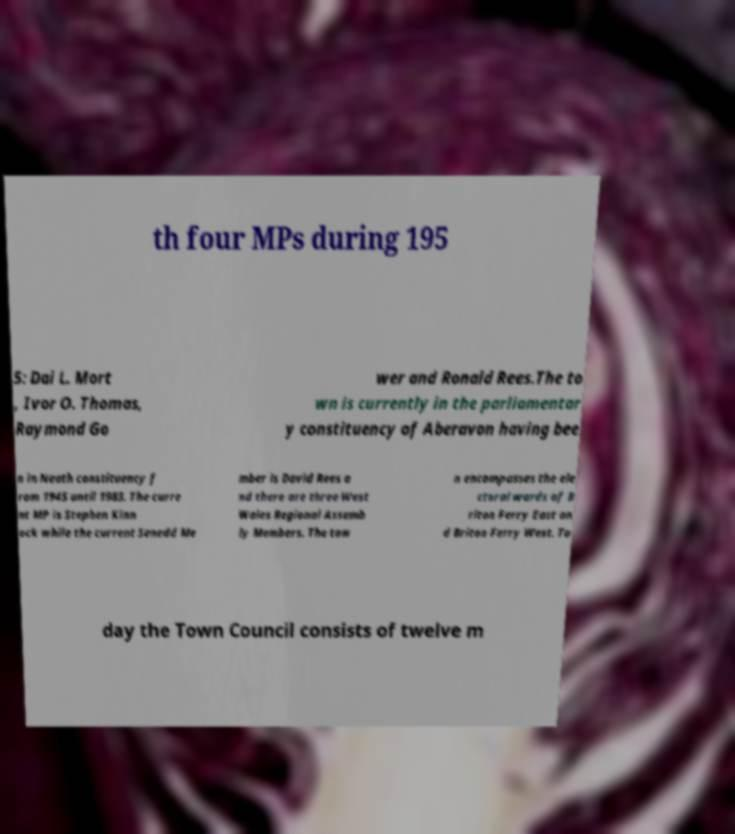There's text embedded in this image that I need extracted. Can you transcribe it verbatim? th four MPs during 195 5: Dai L. Mort , Ivor O. Thomas, Raymond Go wer and Ronald Rees.The to wn is currently in the parliamentar y constituency of Aberavon having bee n in Neath constituency f rom 1945 until 1983. The curre nt MP is Stephen Kinn ock while the current Senedd Me mber is David Rees a nd there are three West Wales Regional Assemb ly Members. The tow n encompasses the ele ctoral wards of B riton Ferry East an d Briton Ferry West. To day the Town Council consists of twelve m 